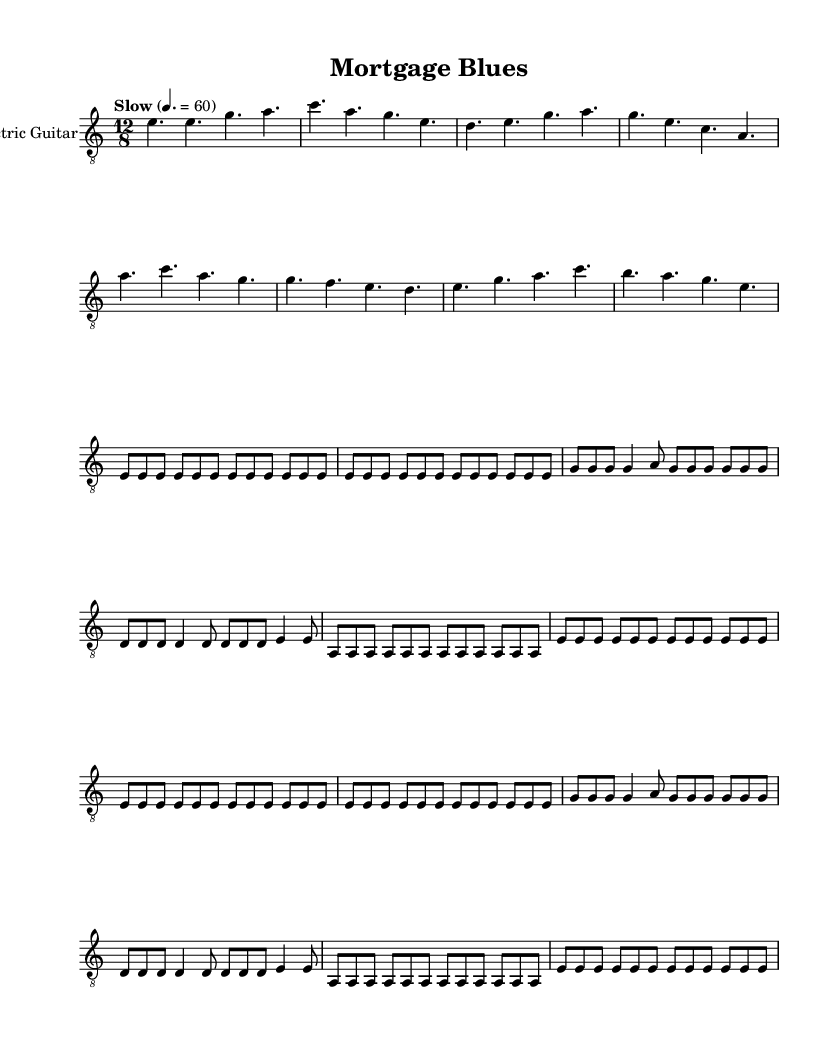What is the key signature of this music? The key signature is A minor, which has no sharps or flats.
Answer: A minor What is the time signature of this piece? The time signature is 12/8, which indicates a compound time feel and groups beats in sets of three.
Answer: 12/8 What is the tempo marking? The tempo marking indicates a slow pace with a tempo of 60 beats per minute, suggesting a relaxed and steady feel typically used in blues music.
Answer: Slow 60 How many bars are in the guitar verse? The guitar verse consists of four measures, as indicated by the grouping and counting of the notes.
Answer: 4 Which musical element is repeated in the guitar riff? The guitar riff contains repetitions of the same rhythmic patterns and note sequences, specifically the E notes are emphasized repeatedly across two measures.
Answer: E notes What mood does the lyrics convey in the chorus? The lyrics describe feelings of discontent and hopelessness, commonly associated with blues music, reflecting the experience of having one's life altered negatively due to circumstances like displacement.
Answer: Discontent How does the structure differentiate between verses and chorus? The structure shows clear separation: verses typically tell a story or express feelings, while the chorus provides a repetitive emotional anchor, serving to emphasize the themes of the song.
Answer: Verses tell a story, chorus emphasizes themes 